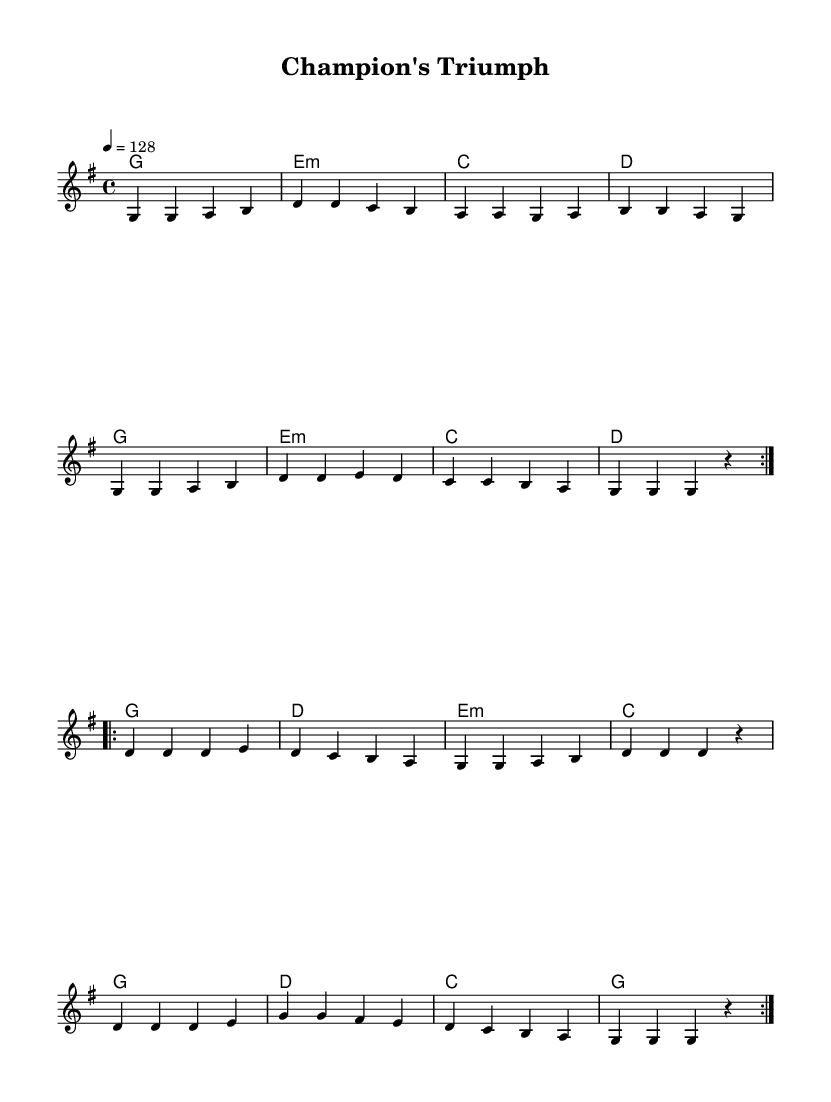What is the key signature of this music? The key signature indicates G major, which has one sharp (F#). This is determined by locating the key signature at the beginning of the staff.
Answer: G major What is the time signature of this music? The time signature at the beginning indicates 4/4, meaning there are four beats per measure, and the quarter note gets one beat. This information is presented as a fraction at the beginning of the piece.
Answer: 4/4 What is the tempo marking for this music? The tempo marking says 4 equals 128, indicating the quarter note gets a tempo of 128 beats per minute. This is listed right after the time signature.
Answer: 128 How many measures are repeated in the first section? The first section repeats two times, as indicated by the "volta" instructions before the measures. Each volta section outlines repeated measures within the music.
Answer: 2 What is the final chord in the harmonies? The last chord in the harmonies is G major, which is identified by examining the chord names at the end of the harmonies section. This indicates the piece resolves on this chord.
Answer: G Which melodic note is used most frequently in the melody? The note G is used most frequently in the melody section, occurring multiple times in the melodic pattern. This can be determined by counting G occurrences in the melody.
Answer: G 